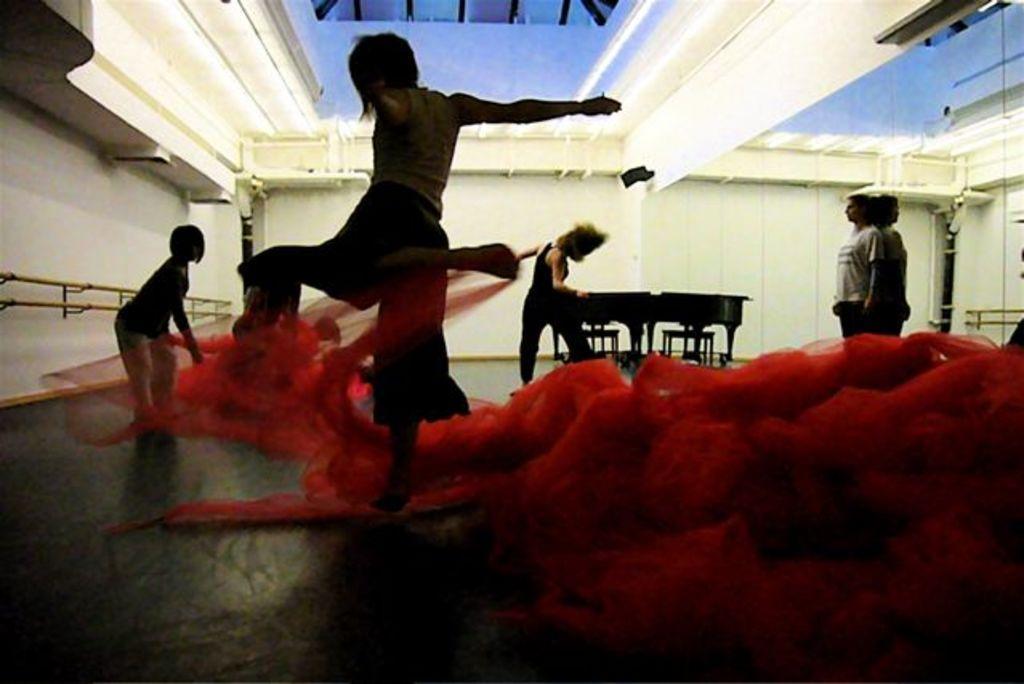Can you describe this image briefly? On the right side of the picture we can see a mirror and the reflection of a person and a wall. Here we can see people, chairs and a table on the floor. 